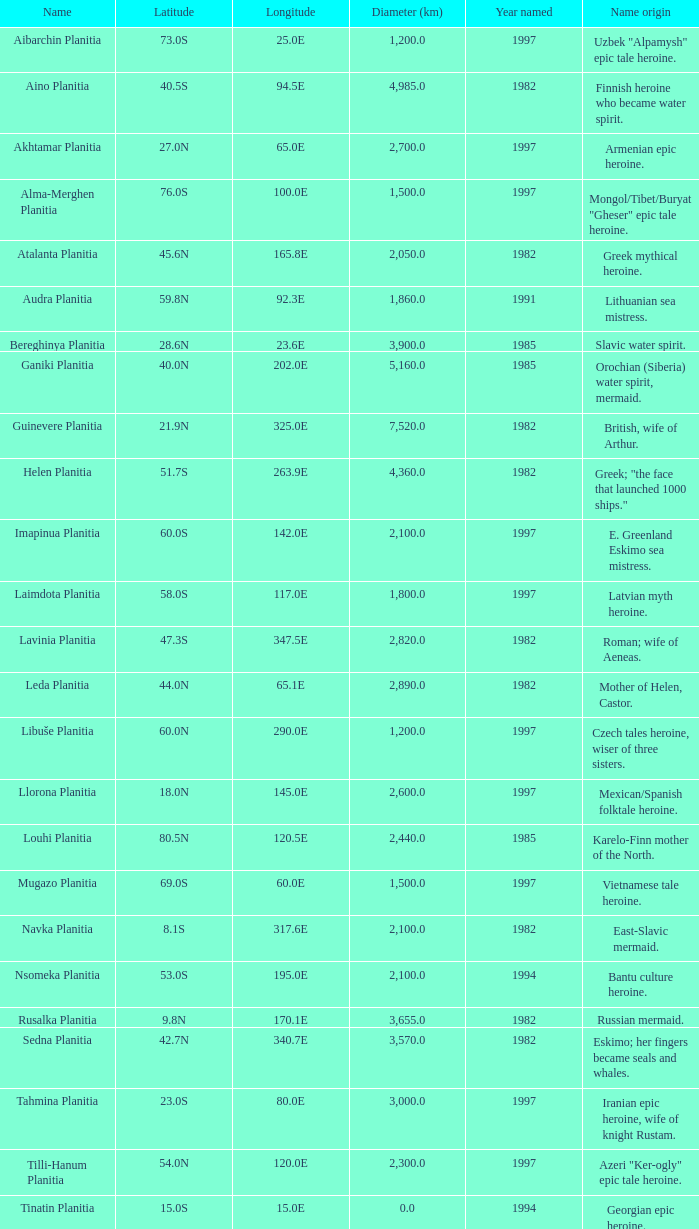What is the source of the name for the feature measuring 2,155.0 kilometers in diameter? Karelo-Finn mermaid. 